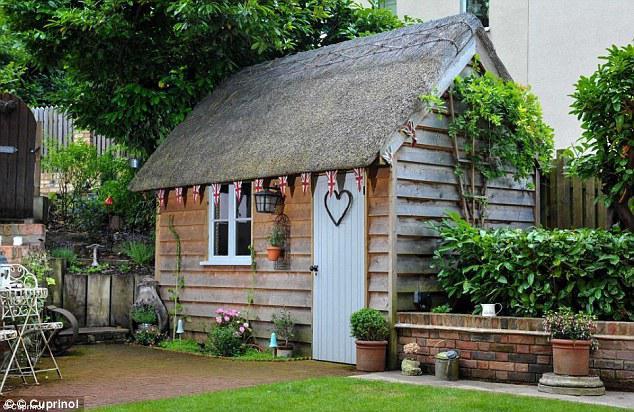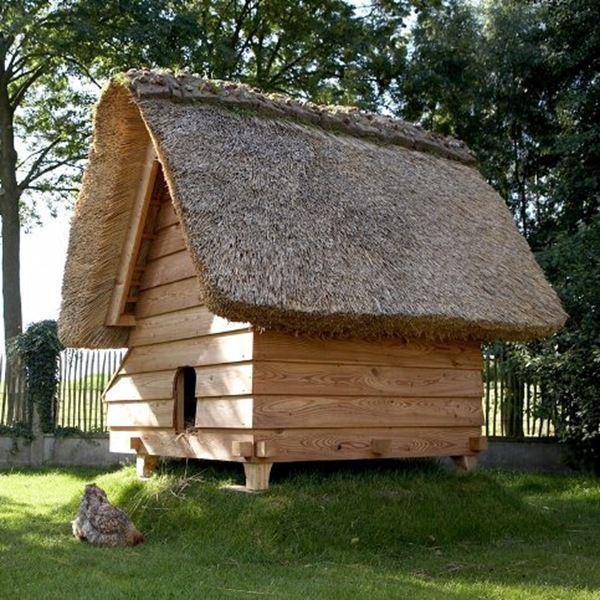The first image is the image on the left, the second image is the image on the right. Given the left and right images, does the statement "The structures on the left and right are simple boxy shapes with peaked thatch roofs featuring some kind of top border, but no curves or notches." hold true? Answer yes or no. Yes. 